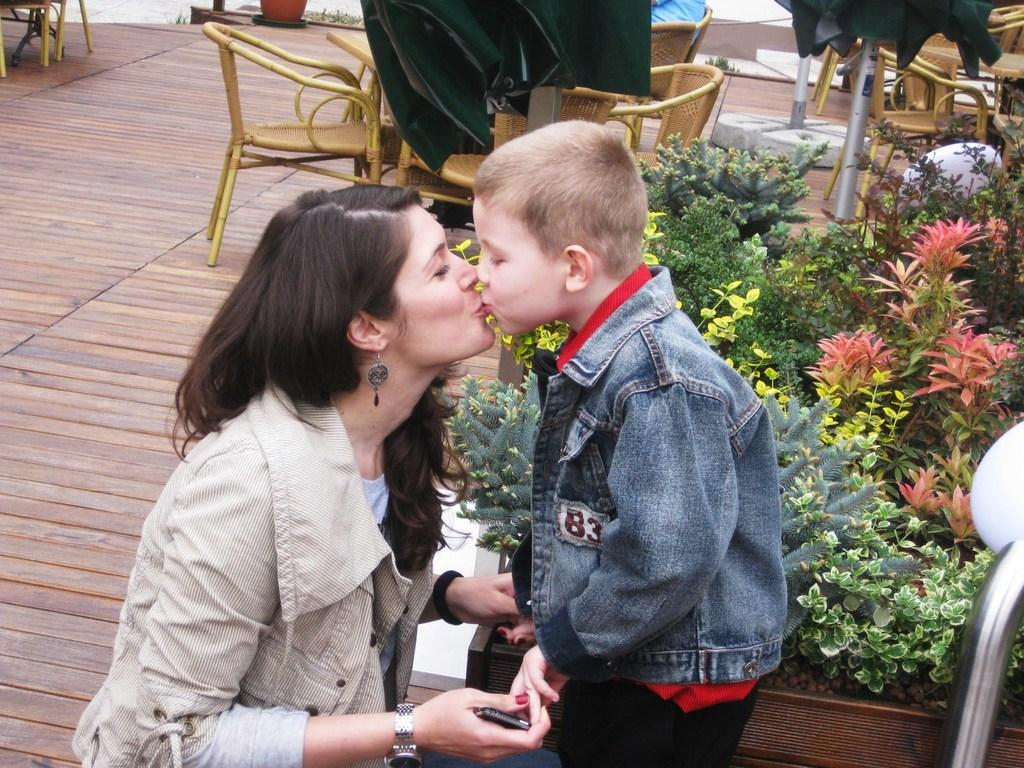What type of location is depicted in the image? The setting appears to be an outdoor restaurant. Who can be seen in the image? There is a boy and a woman in the image. What is the woman wearing? The woman is wearing a jacket. What are the boy and woman doing in the image? The boy and woman are kissing each other. What type of vegetation is present in the image? There are plants beside them. What type of furniture is visible in the image? There are chairs and tables visible in the image. What color is the rose on the table in the image? There is no rose present on the table in the image. What type of flower is blooming in the background of the image? There are no flowers visible in the background of the image. 